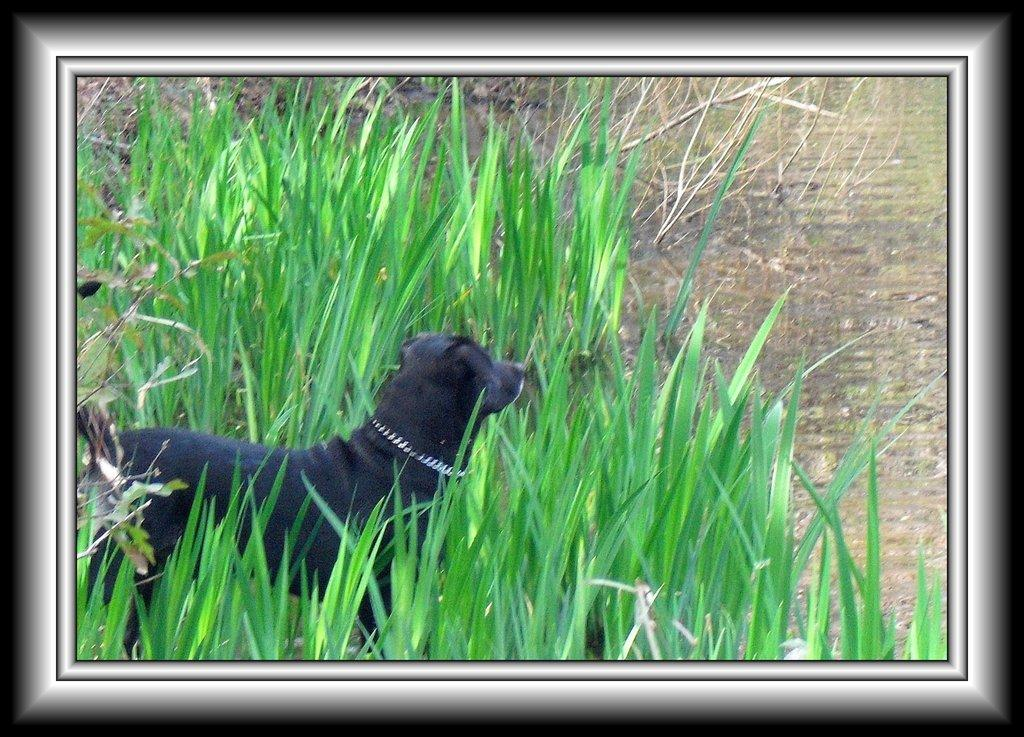What type of animal is in the image? There is a black color dog in the image. What is the background of the image? There is grass visible in the image. How much salt is present in the image? There is no salt present in the image. What type of health benefits can be gained from the dog in the image? The image does not provide any information about health benefits related to the dog. 